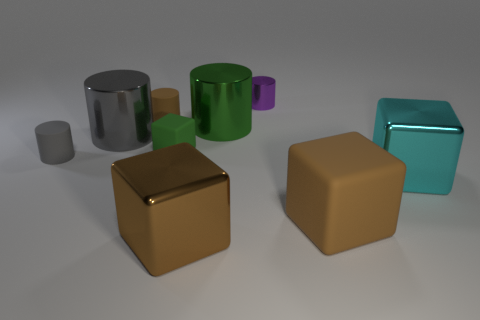There is a metal cylinder that is the same color as the tiny rubber block; what size is it?
Provide a short and direct response. Large. Is there a green cylinder made of the same material as the small purple thing?
Make the answer very short. Yes. What shape is the big metal object that is both on the right side of the big gray metallic object and behind the large cyan object?
Give a very brief answer. Cylinder. What number of other objects are there of the same shape as the green matte object?
Keep it short and to the point. 3. How big is the brown matte cube?
Keep it short and to the point. Large. How many things are green metal things or brown matte cylinders?
Keep it short and to the point. 2. What size is the matte cylinder on the right side of the gray rubber cylinder?
Provide a succinct answer. Small. Is there any other thing that has the same size as the cyan thing?
Your response must be concise. Yes. What is the color of the cylinder that is both behind the green rubber cube and left of the tiny brown cylinder?
Your response must be concise. Gray. Is the brown thing that is behind the big cyan metal object made of the same material as the tiny cube?
Your response must be concise. Yes. 